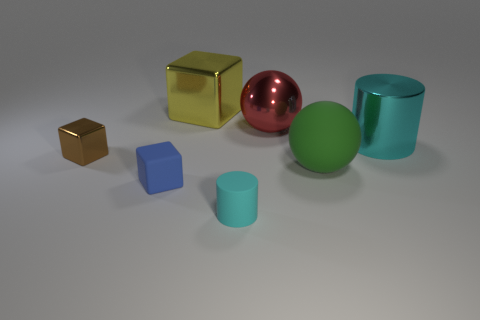Subtract all brown shiny blocks. How many blocks are left? 2 Subtract 2 spheres. How many spheres are left? 0 Add 2 small metal spheres. How many objects exist? 9 Subtract all cylinders. How many objects are left? 5 Subtract all yellow blocks. How many blocks are left? 2 Subtract all cyan spheres. Subtract all brown cubes. How many spheres are left? 2 Subtract all brown cylinders. How many blue balls are left? 0 Subtract all metallic things. Subtract all red metal spheres. How many objects are left? 2 Add 7 blue rubber blocks. How many blue rubber blocks are left? 8 Add 4 tiny cylinders. How many tiny cylinders exist? 5 